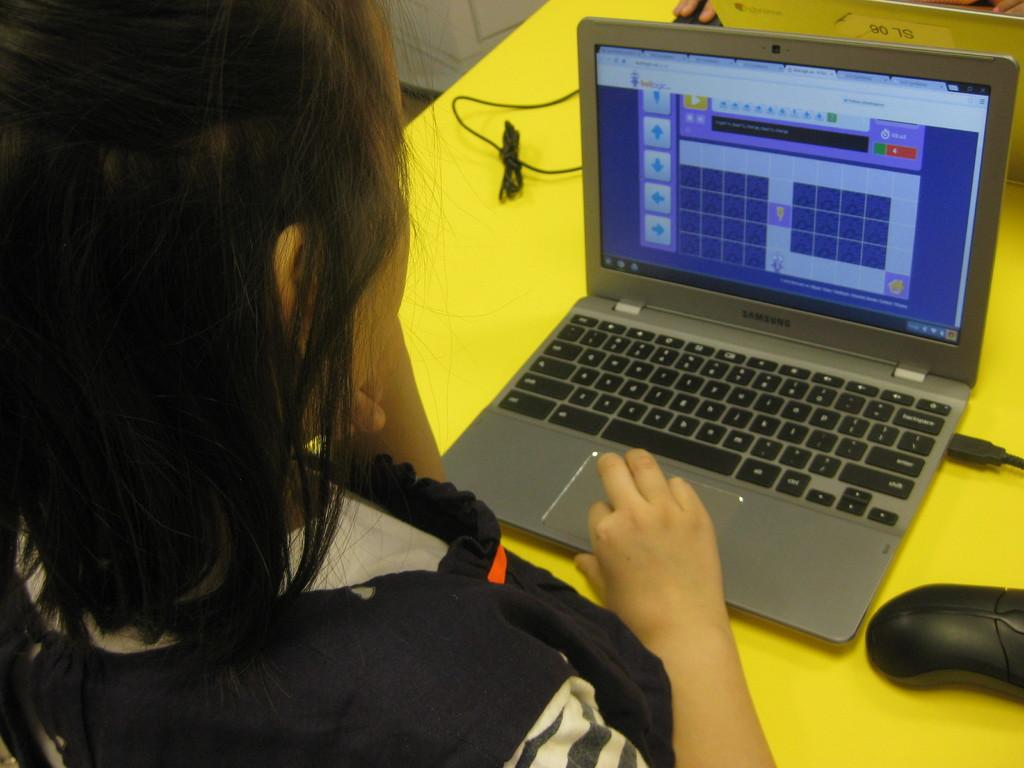Who or what is present in the image? There is a person in the image. What can be seen in the background of the image? There is a yellow table in the image. What electronic devices are visible in the image? There are two laptops and two mouses in the image. Are there any wires present in the image? Yes, there are wires in the image. What is located at the top of the image? There is a screen at the top of the image. What type of army is depicted in the image? There is no army present in the image; it features a person, laptops, mouses, and other objects related to technology. What kind of doll is sitting on the yellow table? There is no doll present in the image; the yellow table has laptops and other objects on it. 